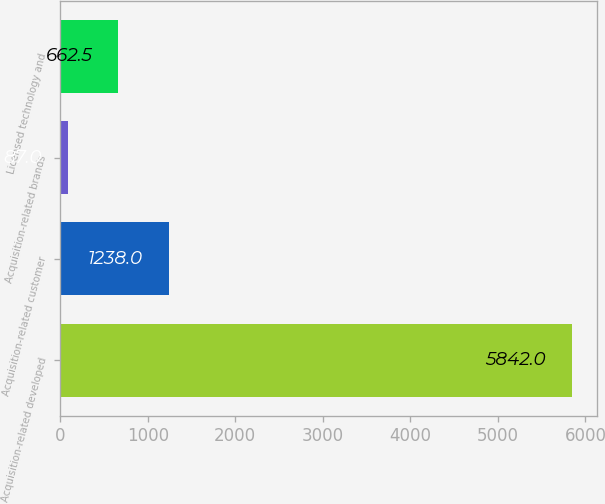Convert chart. <chart><loc_0><loc_0><loc_500><loc_500><bar_chart><fcel>Acquisition-related developed<fcel>Acquisition-related customer<fcel>Acquisition-related brands<fcel>Licensed technology and<nl><fcel>5842<fcel>1238<fcel>87<fcel>662.5<nl></chart> 